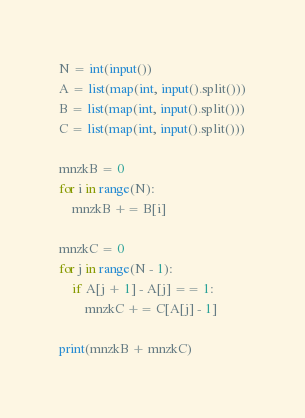Convert code to text. <code><loc_0><loc_0><loc_500><loc_500><_Python_>N = int(input())
A = list(map(int, input().split()))
B = list(map(int, input().split()))
C = list(map(int, input().split()))

mnzkB = 0
for i in range(N):
    mnzkB += B[i]

mnzkC = 0
for j in range(N - 1):
    if A[j + 1] - A[j] == 1:
        mnzkC += C[A[j] - 1]
    
print(mnzkB + mnzkC)</code> 